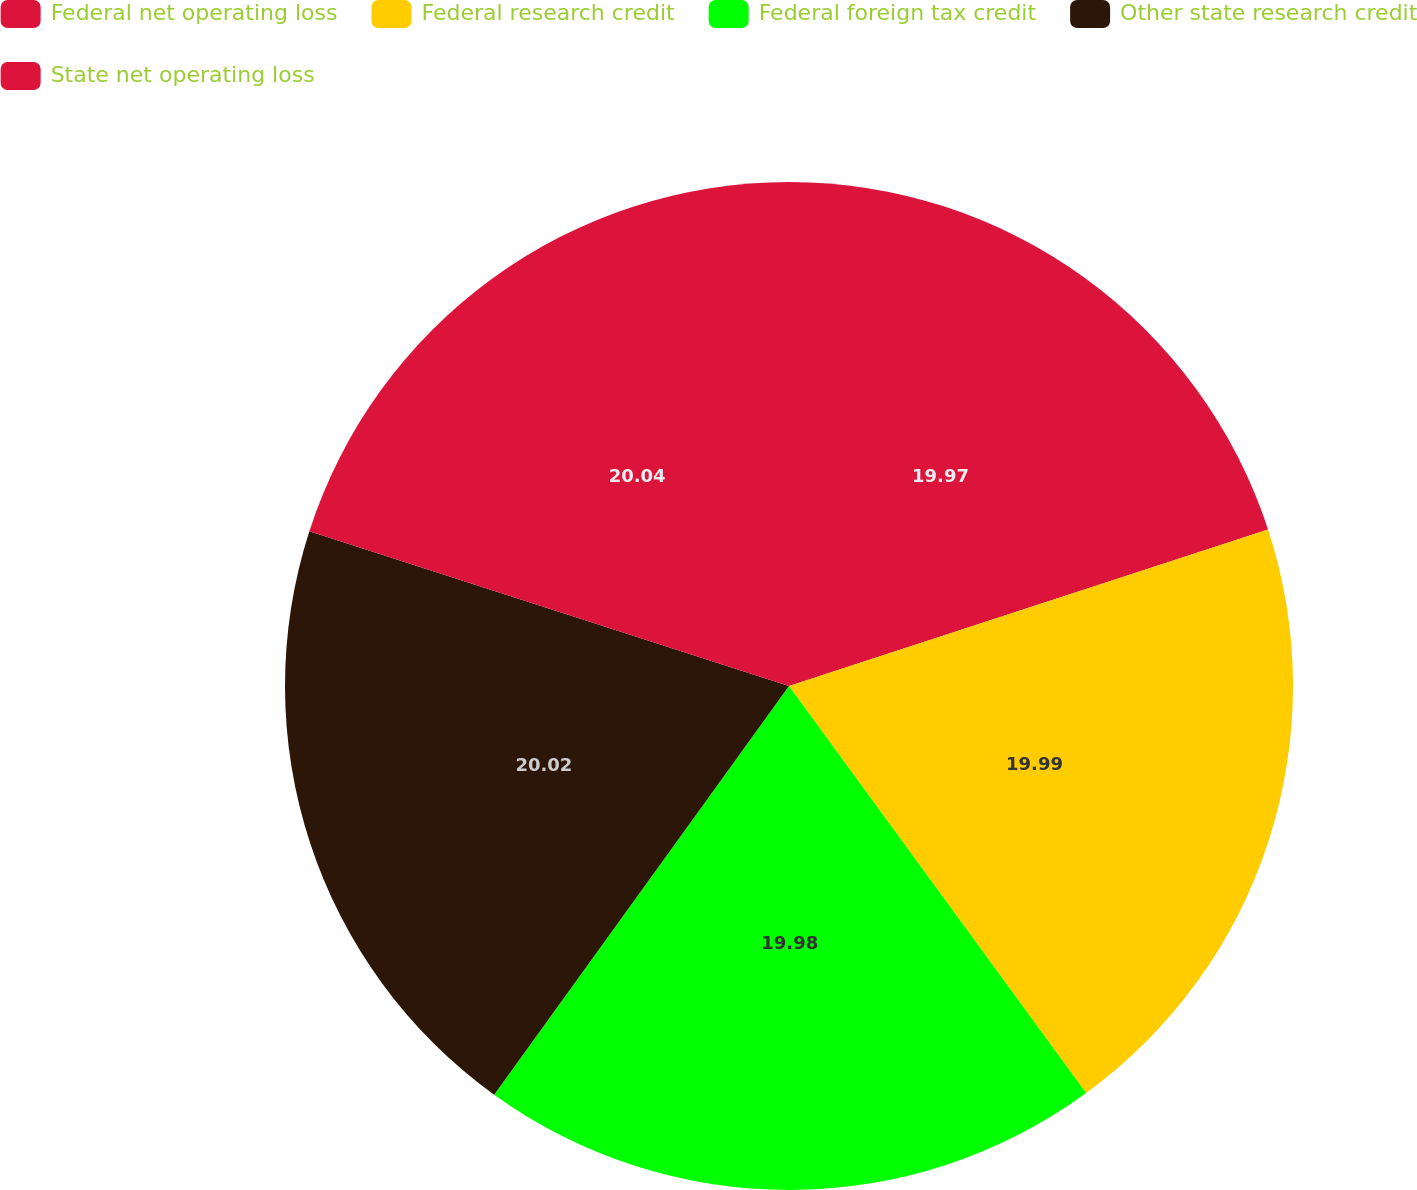<chart> <loc_0><loc_0><loc_500><loc_500><pie_chart><fcel>Federal net operating loss<fcel>Federal research credit<fcel>Federal foreign tax credit<fcel>Other state research credit<fcel>State net operating loss<nl><fcel>19.97%<fcel>19.99%<fcel>19.98%<fcel>20.02%<fcel>20.03%<nl></chart> 